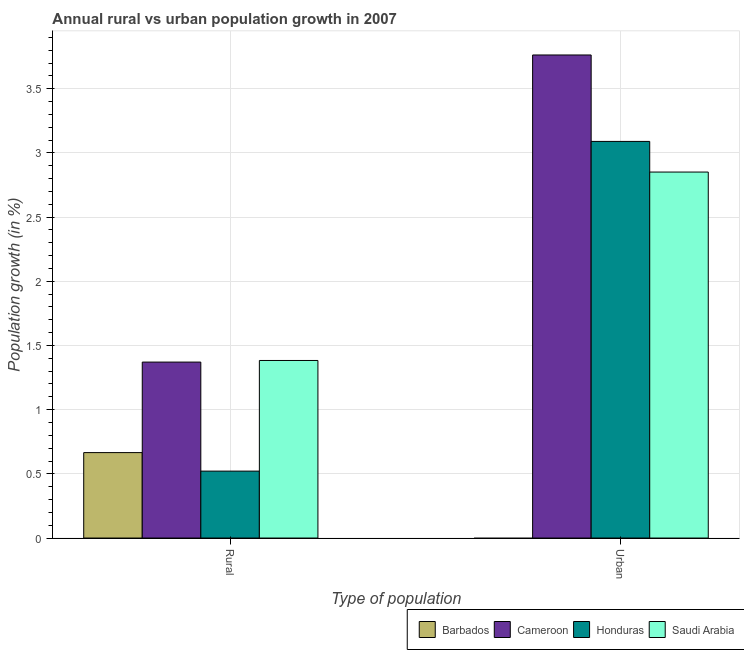How many different coloured bars are there?
Give a very brief answer. 4. How many groups of bars are there?
Ensure brevity in your answer.  2. Are the number of bars per tick equal to the number of legend labels?
Your answer should be compact. No. Are the number of bars on each tick of the X-axis equal?
Ensure brevity in your answer.  No. How many bars are there on the 1st tick from the right?
Your response must be concise. 3. What is the label of the 1st group of bars from the left?
Your answer should be very brief. Rural. Across all countries, what is the maximum rural population growth?
Make the answer very short. 1.38. Across all countries, what is the minimum urban population growth?
Ensure brevity in your answer.  0. In which country was the rural population growth maximum?
Ensure brevity in your answer.  Saudi Arabia. What is the total rural population growth in the graph?
Your answer should be compact. 3.94. What is the difference between the rural population growth in Honduras and that in Cameroon?
Ensure brevity in your answer.  -0.85. What is the difference between the rural population growth in Honduras and the urban population growth in Barbados?
Offer a terse response. 0.52. What is the average urban population growth per country?
Your answer should be very brief. 2.43. What is the difference between the rural population growth and urban population growth in Saudi Arabia?
Make the answer very short. -1.47. In how many countries, is the urban population growth greater than 0.9 %?
Provide a short and direct response. 3. What is the ratio of the rural population growth in Honduras to that in Saudi Arabia?
Provide a succinct answer. 0.38. Is the rural population growth in Saudi Arabia less than that in Honduras?
Your answer should be very brief. No. In how many countries, is the rural population growth greater than the average rural population growth taken over all countries?
Offer a very short reply. 2. How many bars are there?
Your answer should be compact. 7. Are all the bars in the graph horizontal?
Make the answer very short. No. Does the graph contain any zero values?
Provide a short and direct response. Yes. Where does the legend appear in the graph?
Provide a succinct answer. Bottom right. How many legend labels are there?
Offer a terse response. 4. What is the title of the graph?
Your answer should be compact. Annual rural vs urban population growth in 2007. What is the label or title of the X-axis?
Your answer should be compact. Type of population. What is the label or title of the Y-axis?
Provide a short and direct response. Population growth (in %). What is the Population growth (in %) of Barbados in Rural?
Provide a short and direct response. 0.67. What is the Population growth (in %) in Cameroon in Rural?
Provide a succinct answer. 1.37. What is the Population growth (in %) of Honduras in Rural?
Ensure brevity in your answer.  0.52. What is the Population growth (in %) of Saudi Arabia in Rural?
Ensure brevity in your answer.  1.38. What is the Population growth (in %) in Cameroon in Urban ?
Give a very brief answer. 3.76. What is the Population growth (in %) of Honduras in Urban ?
Provide a succinct answer. 3.09. What is the Population growth (in %) in Saudi Arabia in Urban ?
Your response must be concise. 2.85. Across all Type of population, what is the maximum Population growth (in %) in Barbados?
Ensure brevity in your answer.  0.67. Across all Type of population, what is the maximum Population growth (in %) of Cameroon?
Keep it short and to the point. 3.76. Across all Type of population, what is the maximum Population growth (in %) of Honduras?
Offer a very short reply. 3.09. Across all Type of population, what is the maximum Population growth (in %) in Saudi Arabia?
Make the answer very short. 2.85. Across all Type of population, what is the minimum Population growth (in %) of Barbados?
Offer a very short reply. 0. Across all Type of population, what is the minimum Population growth (in %) of Cameroon?
Provide a succinct answer. 1.37. Across all Type of population, what is the minimum Population growth (in %) of Honduras?
Make the answer very short. 0.52. Across all Type of population, what is the minimum Population growth (in %) in Saudi Arabia?
Give a very brief answer. 1.38. What is the total Population growth (in %) of Barbados in the graph?
Offer a very short reply. 0.67. What is the total Population growth (in %) of Cameroon in the graph?
Keep it short and to the point. 5.13. What is the total Population growth (in %) of Honduras in the graph?
Make the answer very short. 3.61. What is the total Population growth (in %) of Saudi Arabia in the graph?
Your answer should be compact. 4.23. What is the difference between the Population growth (in %) of Cameroon in Rural and that in Urban ?
Provide a succinct answer. -2.39. What is the difference between the Population growth (in %) of Honduras in Rural and that in Urban ?
Provide a short and direct response. -2.57. What is the difference between the Population growth (in %) of Saudi Arabia in Rural and that in Urban ?
Offer a terse response. -1.47. What is the difference between the Population growth (in %) in Barbados in Rural and the Population growth (in %) in Cameroon in Urban?
Make the answer very short. -3.1. What is the difference between the Population growth (in %) of Barbados in Rural and the Population growth (in %) of Honduras in Urban?
Your answer should be very brief. -2.42. What is the difference between the Population growth (in %) of Barbados in Rural and the Population growth (in %) of Saudi Arabia in Urban?
Offer a terse response. -2.19. What is the difference between the Population growth (in %) of Cameroon in Rural and the Population growth (in %) of Honduras in Urban?
Your response must be concise. -1.72. What is the difference between the Population growth (in %) in Cameroon in Rural and the Population growth (in %) in Saudi Arabia in Urban?
Your answer should be compact. -1.48. What is the difference between the Population growth (in %) of Honduras in Rural and the Population growth (in %) of Saudi Arabia in Urban?
Your answer should be compact. -2.33. What is the average Population growth (in %) in Barbados per Type of population?
Provide a succinct answer. 0.33. What is the average Population growth (in %) in Cameroon per Type of population?
Provide a succinct answer. 2.57. What is the average Population growth (in %) in Honduras per Type of population?
Ensure brevity in your answer.  1.81. What is the average Population growth (in %) of Saudi Arabia per Type of population?
Provide a succinct answer. 2.12. What is the difference between the Population growth (in %) of Barbados and Population growth (in %) of Cameroon in Rural?
Make the answer very short. -0.71. What is the difference between the Population growth (in %) in Barbados and Population growth (in %) in Honduras in Rural?
Offer a terse response. 0.14. What is the difference between the Population growth (in %) of Barbados and Population growth (in %) of Saudi Arabia in Rural?
Provide a succinct answer. -0.72. What is the difference between the Population growth (in %) of Cameroon and Population growth (in %) of Honduras in Rural?
Make the answer very short. 0.85. What is the difference between the Population growth (in %) in Cameroon and Population growth (in %) in Saudi Arabia in Rural?
Your answer should be compact. -0.01. What is the difference between the Population growth (in %) of Honduras and Population growth (in %) of Saudi Arabia in Rural?
Offer a terse response. -0.86. What is the difference between the Population growth (in %) in Cameroon and Population growth (in %) in Honduras in Urban ?
Offer a terse response. 0.67. What is the difference between the Population growth (in %) in Cameroon and Population growth (in %) in Saudi Arabia in Urban ?
Offer a terse response. 0.91. What is the difference between the Population growth (in %) of Honduras and Population growth (in %) of Saudi Arabia in Urban ?
Ensure brevity in your answer.  0.24. What is the ratio of the Population growth (in %) in Cameroon in Rural to that in Urban ?
Keep it short and to the point. 0.36. What is the ratio of the Population growth (in %) of Honduras in Rural to that in Urban ?
Make the answer very short. 0.17. What is the ratio of the Population growth (in %) in Saudi Arabia in Rural to that in Urban ?
Ensure brevity in your answer.  0.49. What is the difference between the highest and the second highest Population growth (in %) of Cameroon?
Offer a very short reply. 2.39. What is the difference between the highest and the second highest Population growth (in %) of Honduras?
Your response must be concise. 2.57. What is the difference between the highest and the second highest Population growth (in %) of Saudi Arabia?
Offer a terse response. 1.47. What is the difference between the highest and the lowest Population growth (in %) in Barbados?
Your answer should be very brief. 0.67. What is the difference between the highest and the lowest Population growth (in %) of Cameroon?
Your answer should be compact. 2.39. What is the difference between the highest and the lowest Population growth (in %) in Honduras?
Keep it short and to the point. 2.57. What is the difference between the highest and the lowest Population growth (in %) in Saudi Arabia?
Your answer should be compact. 1.47. 